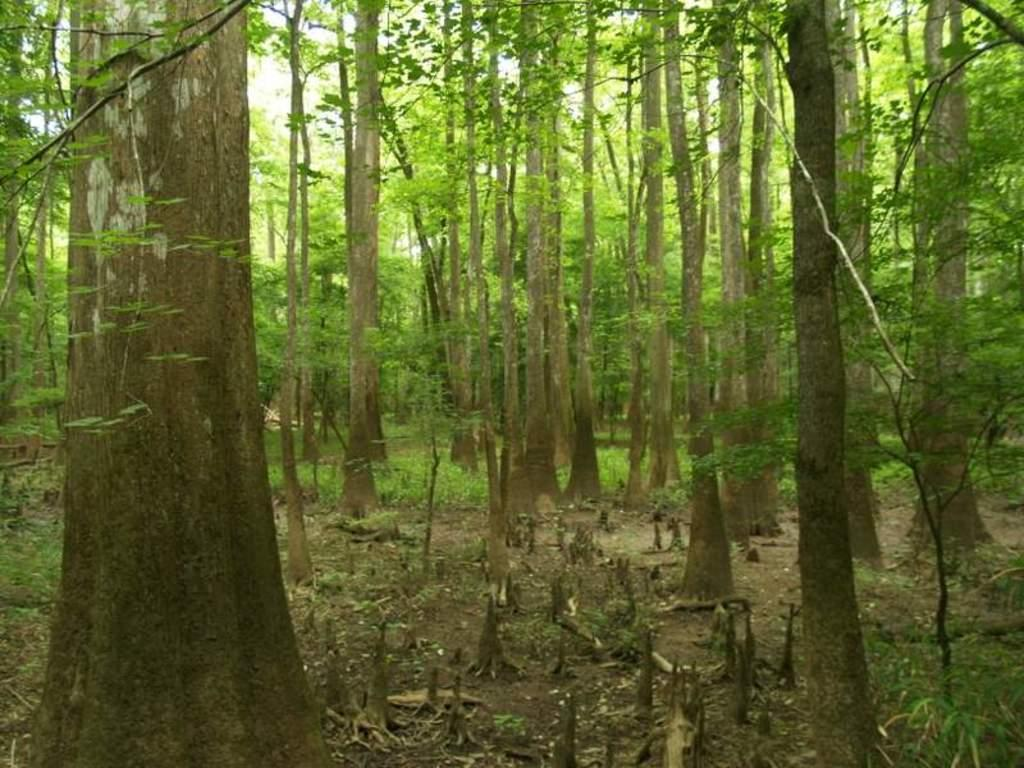What type of vegetation is present in the image? There are many trees in the image. What can be found on the ground beneath the trees? There are dry leaves and wooden pieces on the ground. What type of flower can be seen growing on the trees in the image? There are no flowers mentioned or visible in the image; it only features trees, dry leaves, and wooden pieces on the ground. 